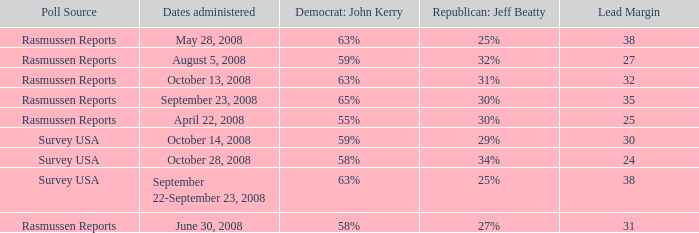Could you parse the entire table as a dict? {'header': ['Poll Source', 'Dates administered', 'Democrat: John Kerry', 'Republican: Jeff Beatty', 'Lead Margin'], 'rows': [['Rasmussen Reports', 'May 28, 2008', '63%', '25%', '38'], ['Rasmussen Reports', 'August 5, 2008', '59%', '32%', '27'], ['Rasmussen Reports', 'October 13, 2008', '63%', '31%', '32'], ['Rasmussen Reports', 'September 23, 2008', '65%', '30%', '35'], ['Rasmussen Reports', 'April 22, 2008', '55%', '30%', '25'], ['Survey USA', 'October 14, 2008', '59%', '29%', '30'], ['Survey USA', 'October 28, 2008', '58%', '34%', '24'], ['Survey USA', 'September 22-September 23, 2008', '63%', '25%', '38'], ['Rasmussen Reports', 'June 30, 2008', '58%', '27%', '31']]} What is the percentage for john kerry and dates administered is april 22, 2008? 55%. 